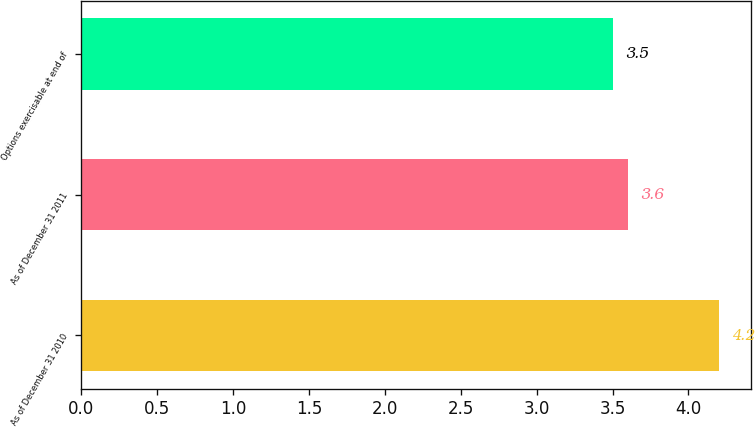<chart> <loc_0><loc_0><loc_500><loc_500><bar_chart><fcel>As of December 31 2010<fcel>As of December 31 2011<fcel>Options exercisable at end of<nl><fcel>4.2<fcel>3.6<fcel>3.5<nl></chart> 